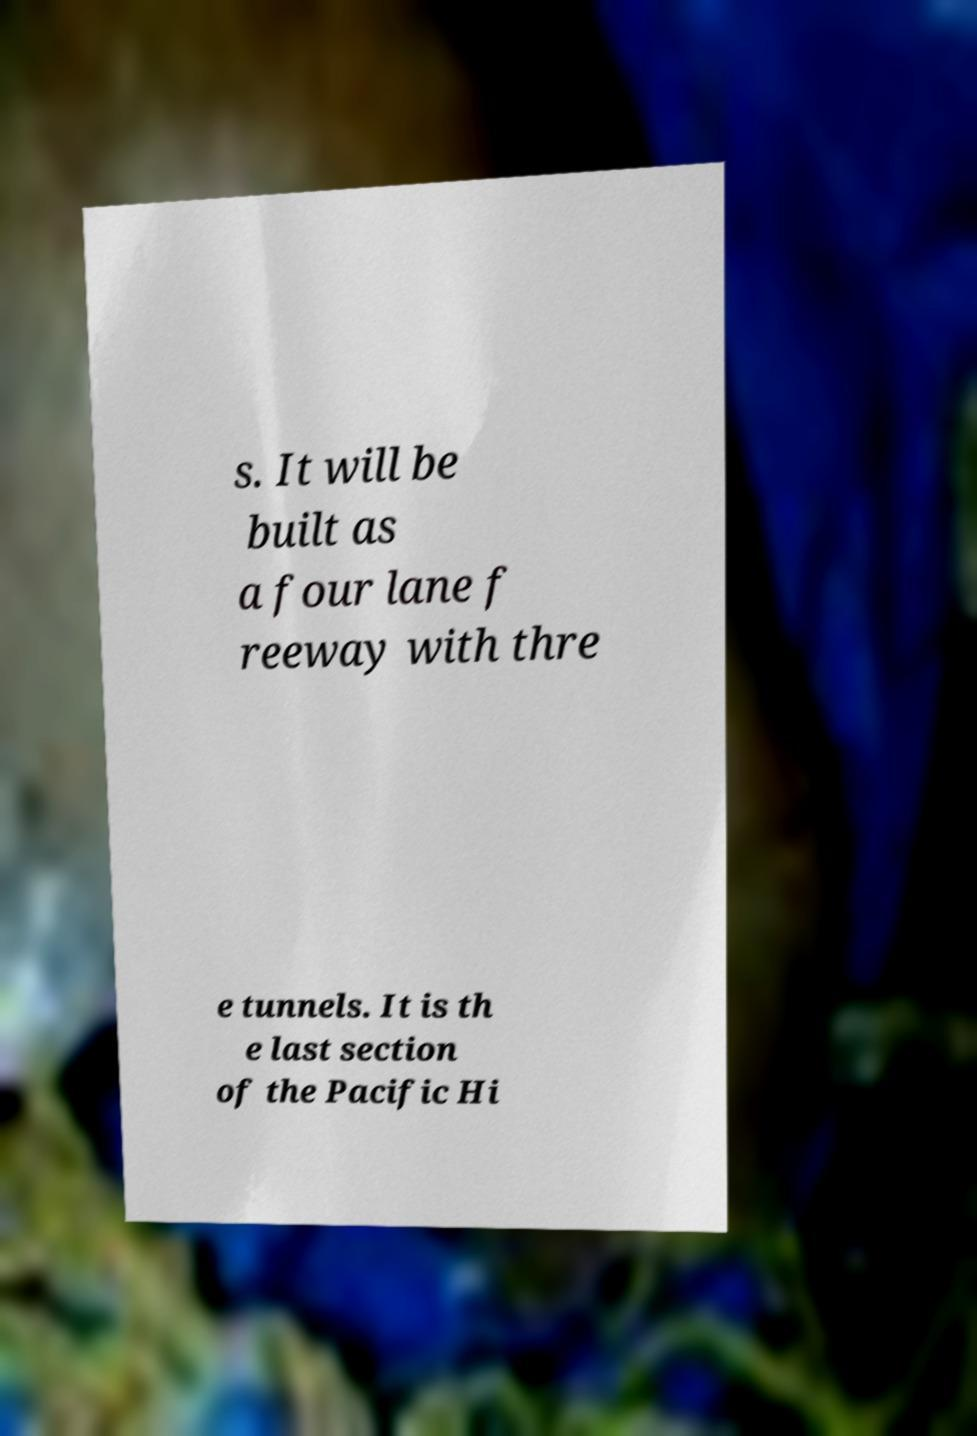Could you extract and type out the text from this image? s. It will be built as a four lane f reeway with thre e tunnels. It is th e last section of the Pacific Hi 